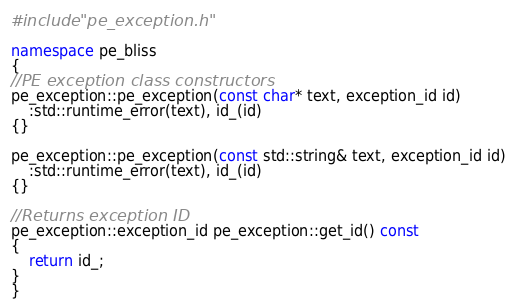Convert code to text. <code><loc_0><loc_0><loc_500><loc_500><_C++_>#include "pe_exception.h"

namespace pe_bliss
{
//PE exception class constructors
pe_exception::pe_exception(const char* text, exception_id id)
    :std::runtime_error(text), id_(id)
{}

pe_exception::pe_exception(const std::string& text, exception_id id)
    :std::runtime_error(text), id_(id)
{}

//Returns exception ID
pe_exception::exception_id pe_exception::get_id() const
{
    return id_;
}
}
</code> 